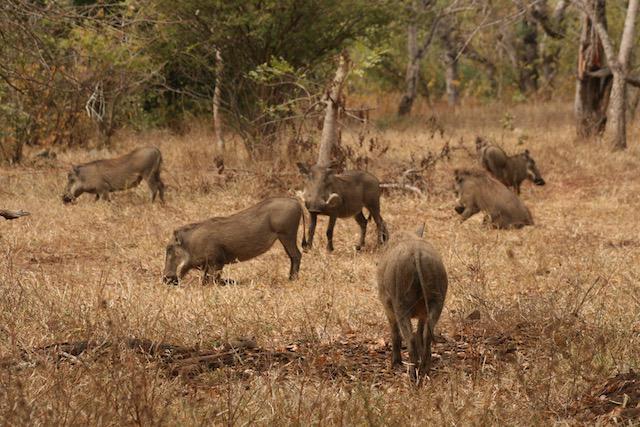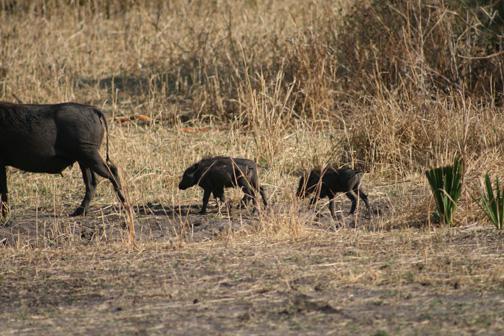The first image is the image on the left, the second image is the image on the right. For the images shown, is this caption "One image contains no more than three animals." true? Answer yes or no. No. 